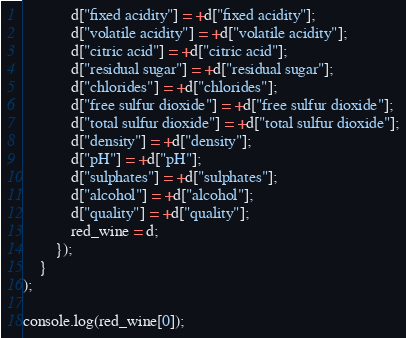<code> <loc_0><loc_0><loc_500><loc_500><_JavaScript_>		    d["fixed acidity"] = +d["fixed acidity"];
		    d["volatile acidity"] = +d["volatile acidity"];
		    d["citric acid"] = +d["citric acid"];
		    d["residual sugar"] = +d["residual sugar"];
		    d["chlorides"] = +d["chlorides"];
		    d["free sulfur dioxide"] = +d["free sulfur dioxide"];
		    d["total sulfur dioxide"] = +d["total sulfur dioxide"];
		    d["density"] = +d["density"];
		    d["pH"] = +d["pH"];
		    d["sulphates"] = +d["sulphates"];
		    d["alcohol"] = +d["alcohol"];
		    d["quality"] = +d["quality"];
		    red_wine = d;
		});
	}
);

console.log(red_wine[0]);</code> 